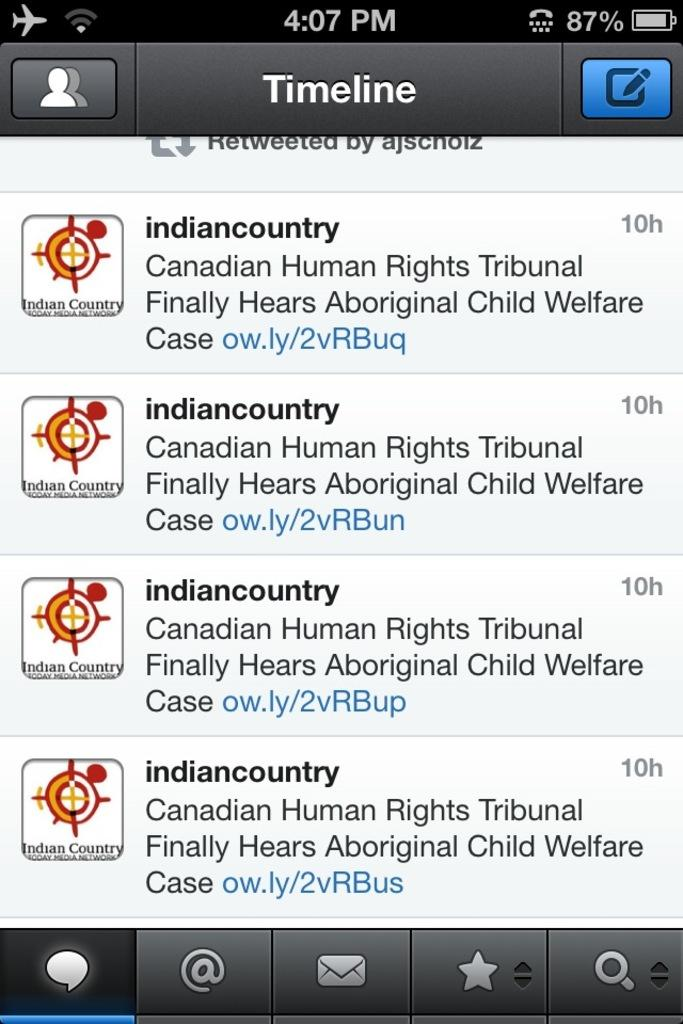<image>
Relay a brief, clear account of the picture shown. An app called Timeline gives information about the Canadian Human Rights Tribunal. 